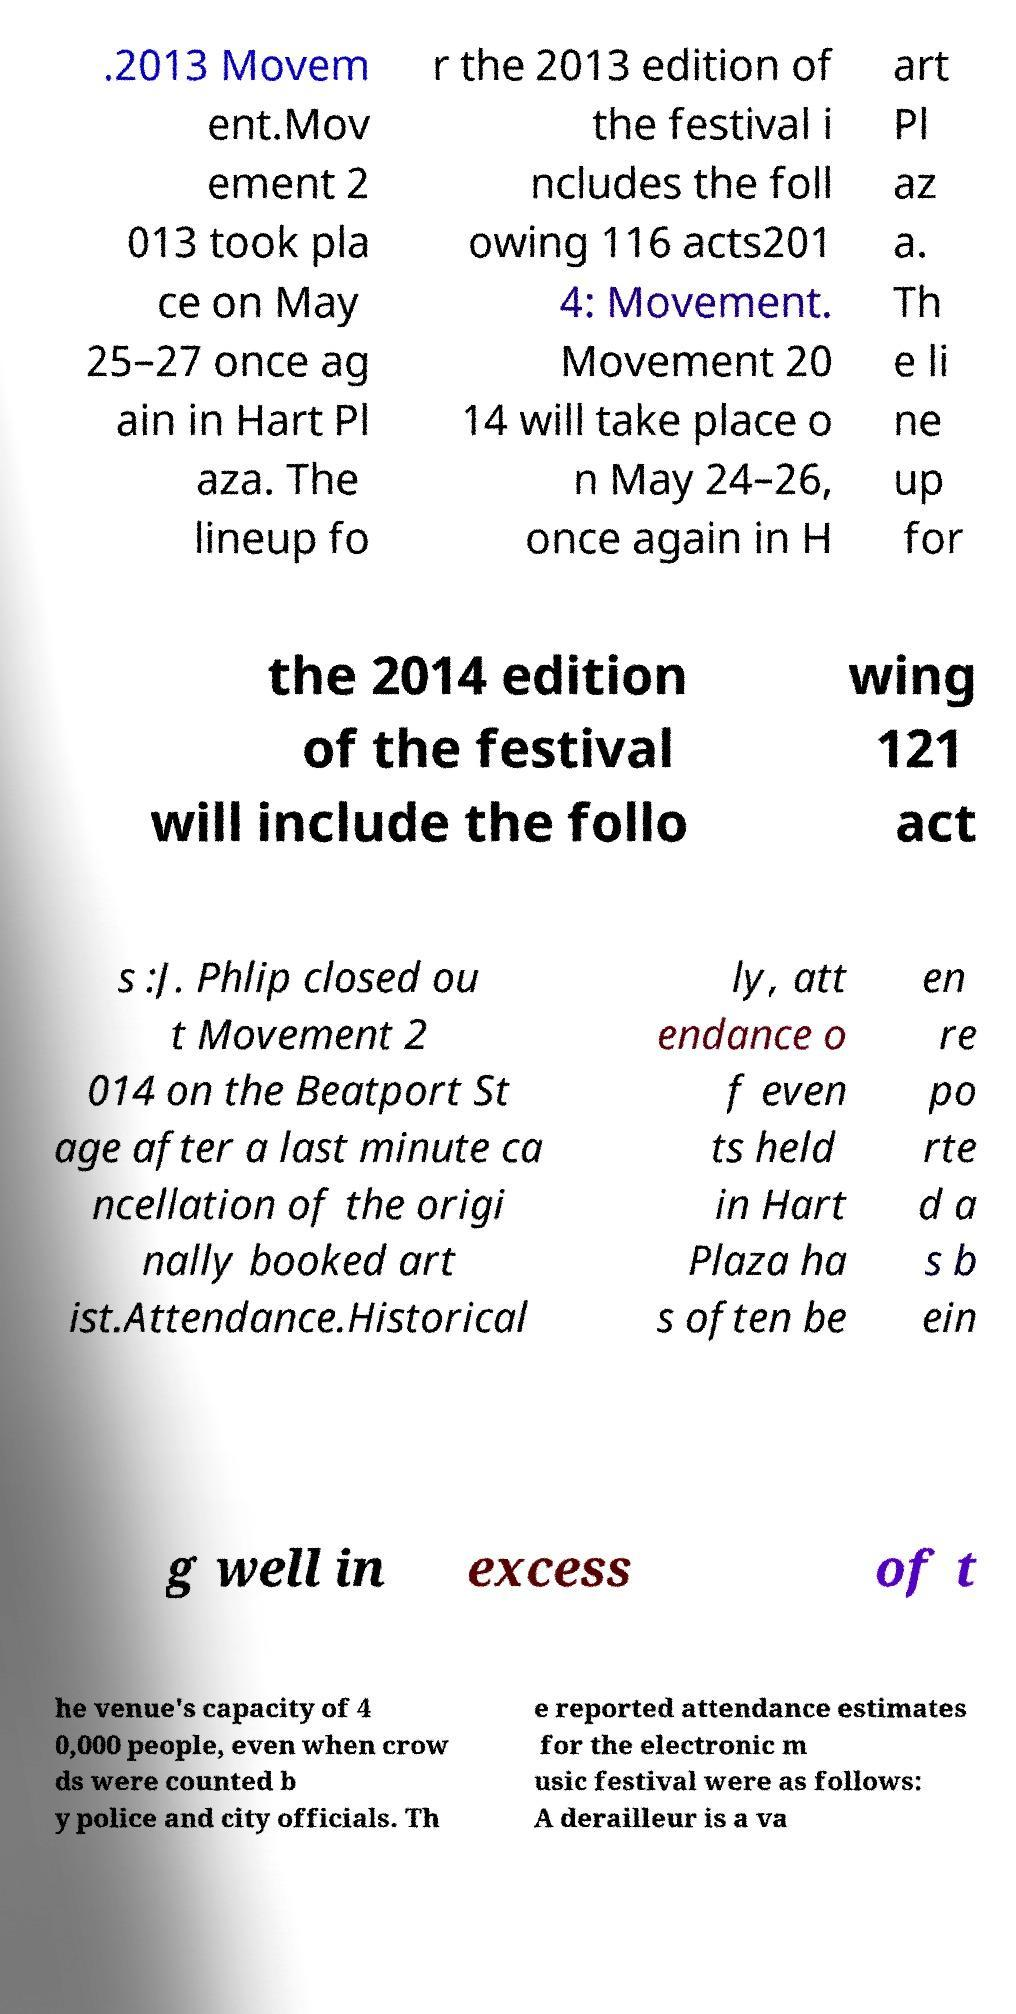Could you assist in decoding the text presented in this image and type it out clearly? .2013 Movem ent.Mov ement 2 013 took pla ce on May 25–27 once ag ain in Hart Pl aza. The lineup fo r the 2013 edition of the festival i ncludes the foll owing 116 acts201 4: Movement. Movement 20 14 will take place o n May 24–26, once again in H art Pl az a. Th e li ne up for the 2014 edition of the festival will include the follo wing 121 act s :J. Phlip closed ou t Movement 2 014 on the Beatport St age after a last minute ca ncellation of the origi nally booked art ist.Attendance.Historical ly, att endance o f even ts held in Hart Plaza ha s often be en re po rte d a s b ein g well in excess of t he venue's capacity of 4 0,000 people, even when crow ds were counted b y police and city officials. Th e reported attendance estimates for the electronic m usic festival were as follows: A derailleur is a va 